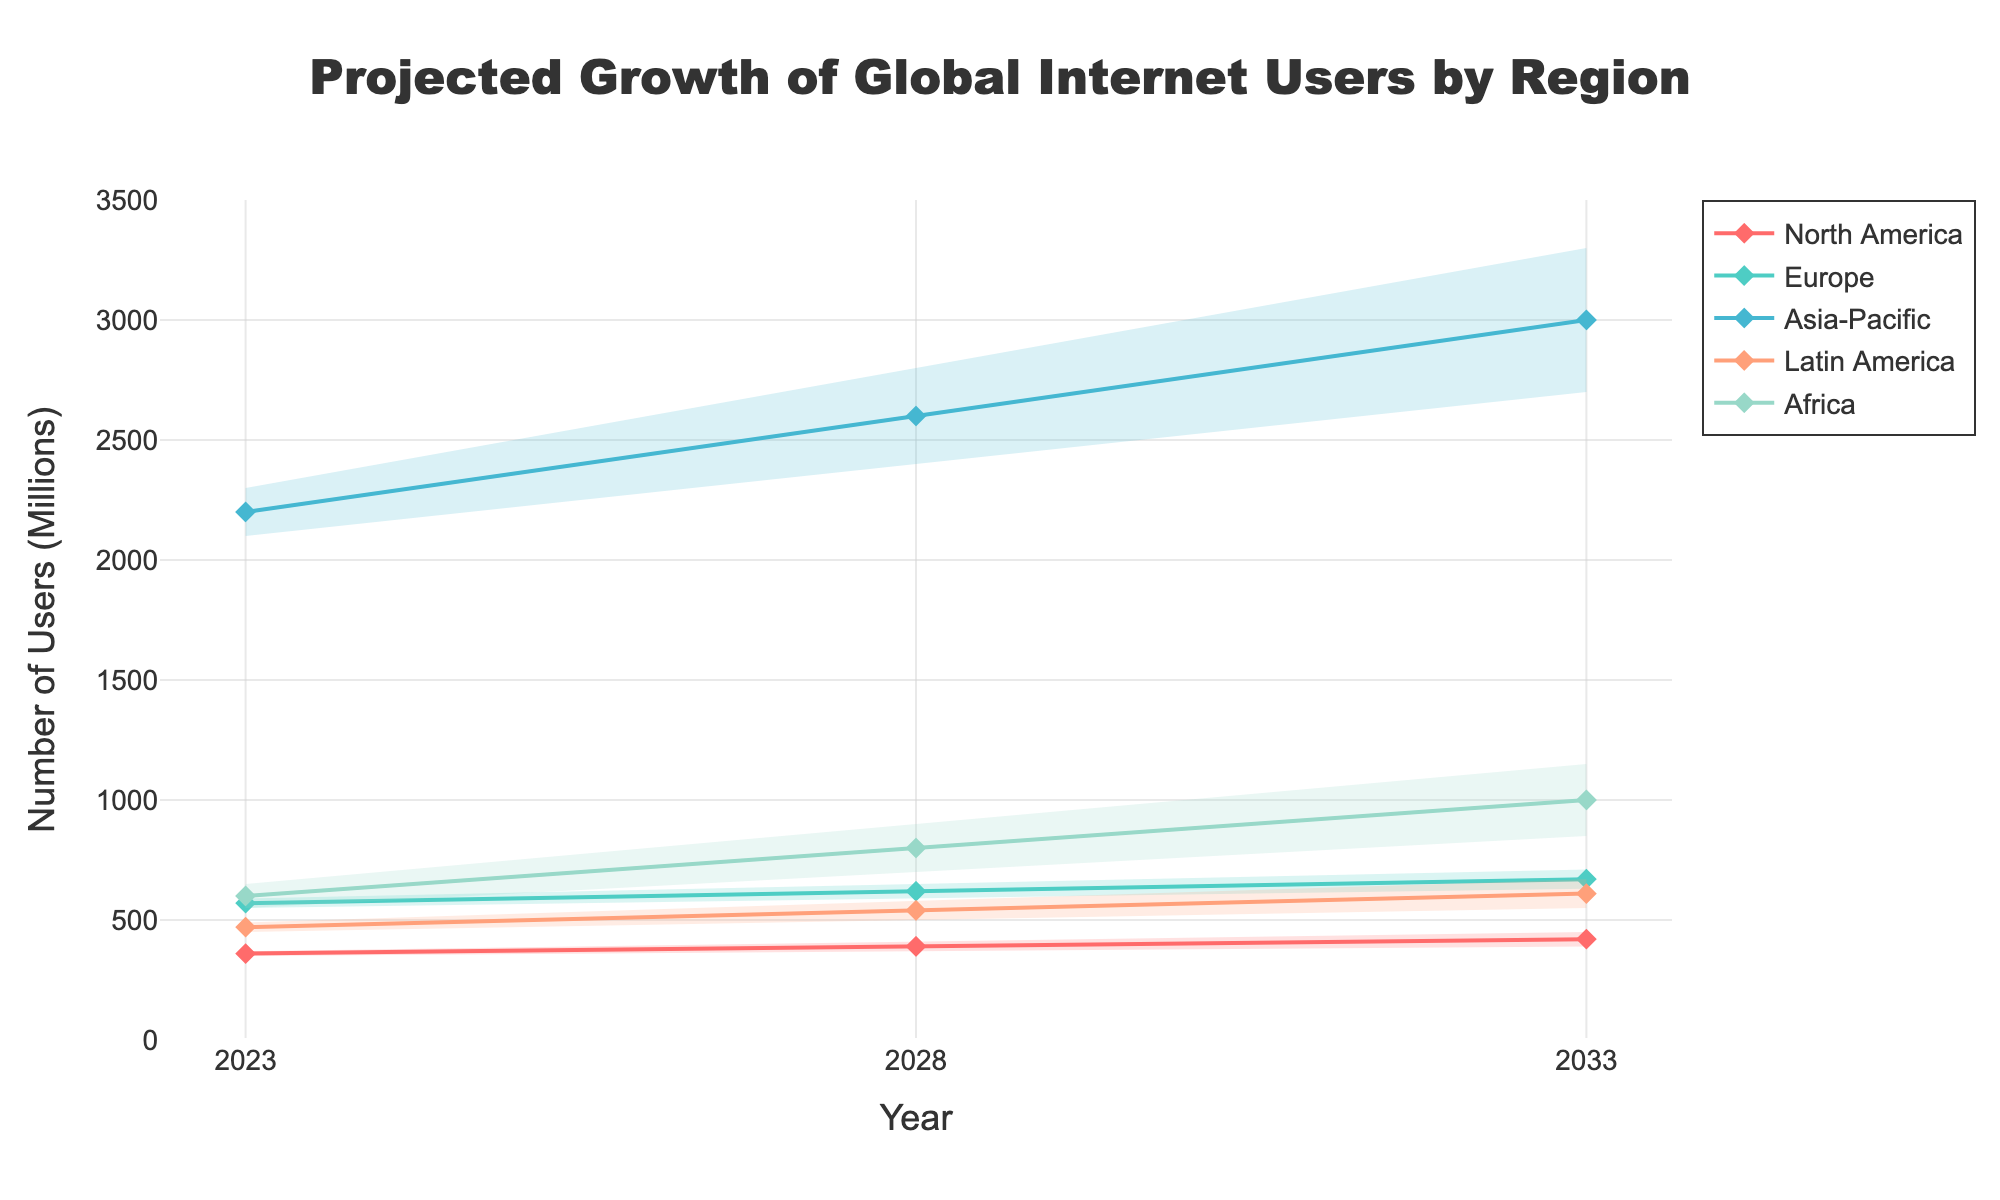What is the title of the figure? The title is usually displayed at the top of the figure in a larger font size to describe what the figure represents.
Answer: Projected Growth of Global Internet Users by Region What are the five regions represented in the figure? The regions are displayed as distinct lines with different colors on the figure. Each region is labeled in the legend.
Answer: North America, Europe, Asia-Pacific, Latin America, Africa Which region is projected to have the highest number of internet users in 2023 based on the middle projection (Mid)? To find this, look at the vertical position of the middle points (Mid) for 2023 across all regions and identify which one is highest.
Answer: Asia-Pacific How does the projected number of users in Africa in 2033 compare to Europe in the same year, based on their median (Mid) values? Compare the Mid values for Africa and Europe in the year 2033 as indicated by the lines and markers.
Answer: Africa has a higher projected number than Europe What is the projection range for Latin America in 2028? To determine the range, observe the lowest (Low) and highest (High) values projected for Latin America in the year 2028.
Answer: 500 to 580 million Which region is projected to see the largest increase in the median number of users from 2023 to 2033? Calculate the difference in the Mid values between 2023 and 2033 for all regions and identify the region with the largest difference.
Answer: Asia-Pacific What is the average number of internet users for North America in 2023 based on the mid-range projection (Mid)? The Mid value itself represents the midpoint of the projection for North America in 2023, effectively serving as the average.
Answer: 360 million Are any regions projected to have overlapping user numbers by 2033, based on the high projections? Check the high (High) projections for each region in 2033 to see if any values overlap or are very close to each other.
Answer: No overlaps Which region shows the smallest increase in the high projection from 2023 to 2033? Calculate the difference in High values from 2023 to 2033 for each region. Then, identify the region with the smallest increase.
Answer: North America How many millions of users is Africa projected to gain from 2028 to 2033 according to the median (Mid) projections? Subtract the Mid projection for Africa in 2028 from the Mid projection for Africa in 2033.
Answer: 200 million 